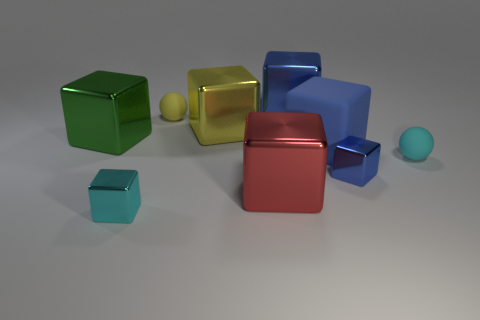How many objects are either cyan matte objects or green metal objects?
Provide a short and direct response. 2. There is a matte object that is left of the large yellow object; does it have the same shape as the tiny rubber object that is to the right of the big blue metal object?
Keep it short and to the point. Yes. How many big objects are behind the large red block and right of the tiny yellow matte ball?
Your response must be concise. 3. How many other objects are the same size as the yellow rubber sphere?
Make the answer very short. 3. There is a thing that is both on the left side of the yellow rubber object and on the right side of the big green block; what material is it?
Ensure brevity in your answer.  Metal. Do the rubber block and the tiny metallic cube to the right of the red shiny thing have the same color?
Provide a short and direct response. Yes. The red object that is the same shape as the big green thing is what size?
Provide a succinct answer. Large. There is a small object that is both to the left of the blue matte thing and behind the red metallic block; what shape is it?
Make the answer very short. Sphere. Do the cyan rubber thing and the matte ball that is left of the cyan rubber object have the same size?
Your response must be concise. Yes. The other matte object that is the same shape as the large yellow object is what color?
Make the answer very short. Blue. 